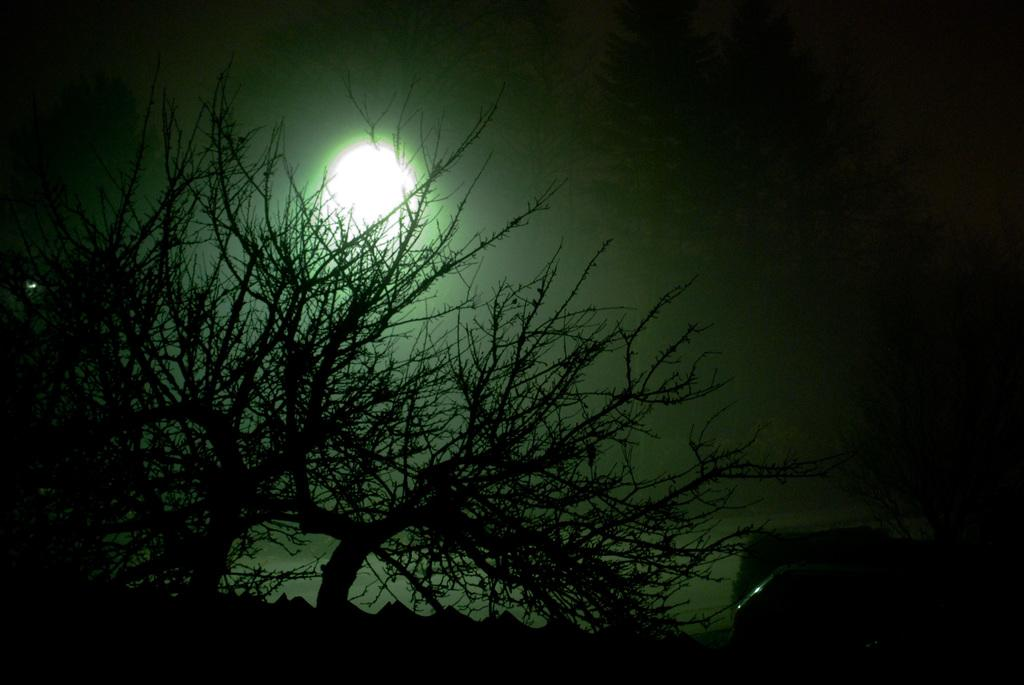Where was the picture taken? The picture was clicked outside. What can be seen in the foreground of the image? There are objects in the foreground of the image. What type of vegetation is visible in the background of the image? There are trees in the background of the image. What celestial body can be seen in the sky in the background of the image? The moon is visible in the sky in the background of the image. How many beggars are visible in the image? There are no beggars present in the image. Is the airplane folded in the image? There is no airplane present in the image, so it cannot be folded or unfolded. 